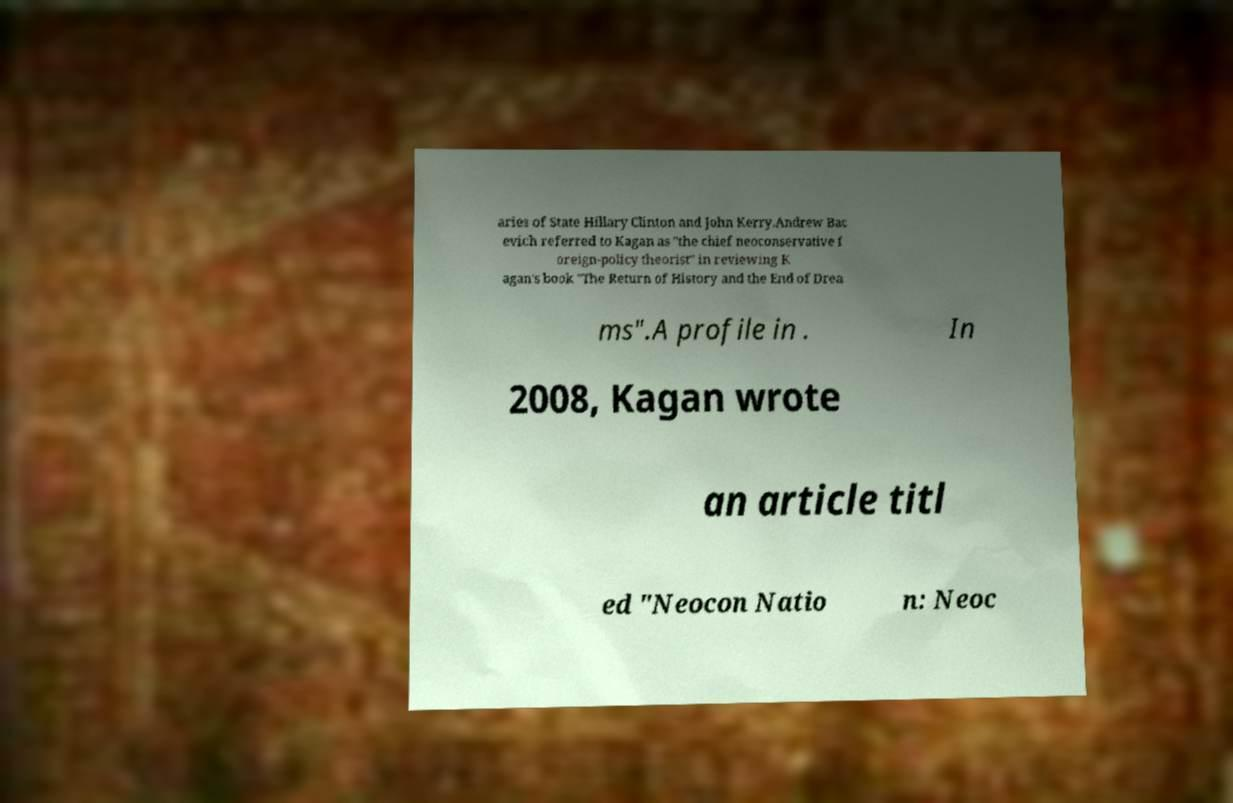What messages or text are displayed in this image? I need them in a readable, typed format. aries of State Hillary Clinton and John Kerry.Andrew Bac evich referred to Kagan as "the chief neoconservative f oreign-policy theorist" in reviewing K agan's book "The Return of History and the End of Drea ms".A profile in . In 2008, Kagan wrote an article titl ed "Neocon Natio n: Neoc 